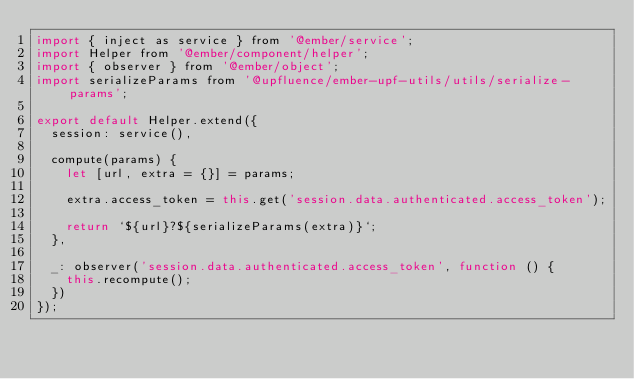<code> <loc_0><loc_0><loc_500><loc_500><_JavaScript_>import { inject as service } from '@ember/service';
import Helper from '@ember/component/helper';
import { observer } from '@ember/object';
import serializeParams from '@upfluence/ember-upf-utils/utils/serialize-params';

export default Helper.extend({
  session: service(),

  compute(params) {
    let [url, extra = {}] = params;

    extra.access_token = this.get('session.data.authenticated.access_token');

    return `${url}?${serializeParams(extra)}`;
  },

  _: observer('session.data.authenticated.access_token', function () {
    this.recompute();
  })
});
</code> 